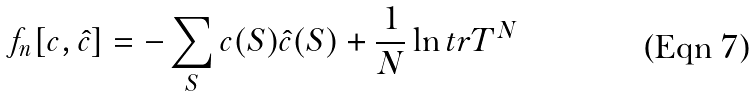<formula> <loc_0><loc_0><loc_500><loc_500>f _ { n } [ c , \hat { c } ] = - \sum _ { S } c ( { S } ) \hat { c } ( { S } ) + \frac { 1 } { N } \ln t r { T } ^ { N }</formula> 